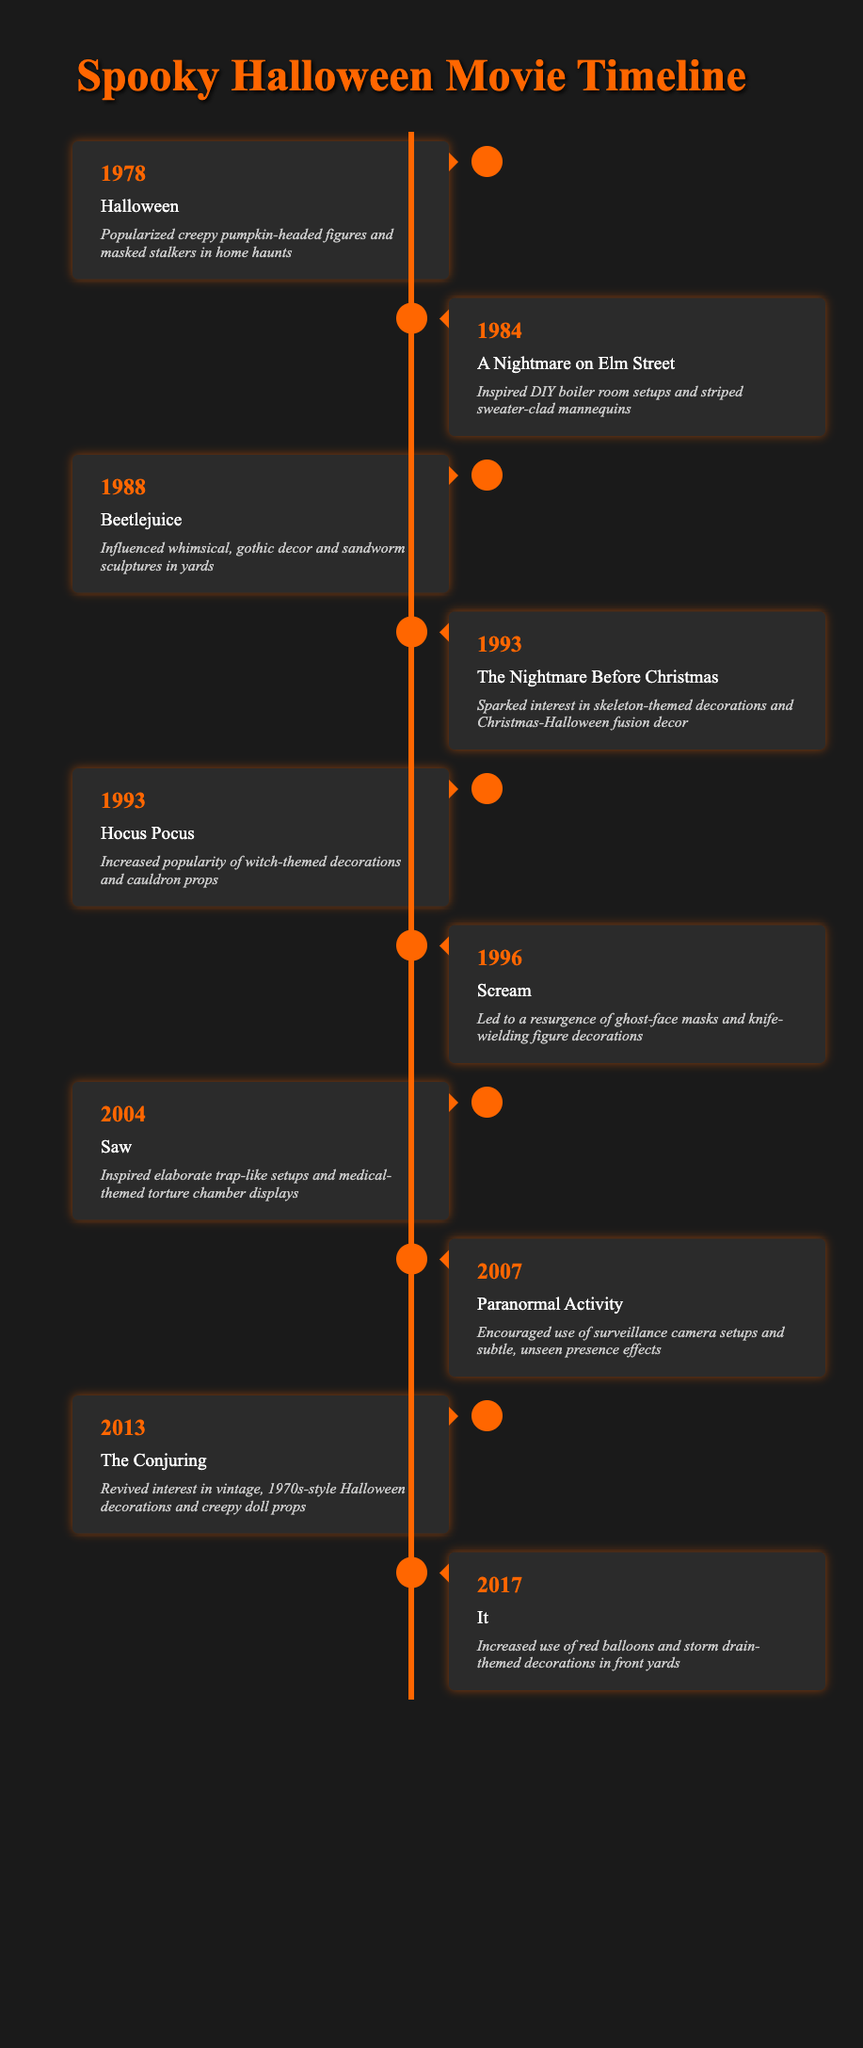What impact did the movie "Hocus Pocus" have on Halloween decorations? "Hocus Pocus" increased the popularity of witch-themed decorations and cauldron props, as stated in the timeline.
Answer: Increased popularity of witch-themed decorations and cauldron props Which movie released in 1993 contributed to skeleton-themed decorations? The timeline shows that "The Nightmare Before Christmas," released in 1993, sparked an interest in skeleton-themed decorations.
Answer: The Nightmare Before Christmas How many movies from the list were released in the 1990s? The years in the table between 1990 and 1999 include "The Nightmare Before Christmas" (1993), "Hocus Pocus" (1993), and "Scream" (1996), totaling three movies.
Answer: 3 Did "Saw" inspire any specific decoration themes? Yes, "Saw" inspired elaborate trap-like setups and medical-themed torture chamber displays, according to its entry in the timeline.
Answer: Yes What year saw the release of "Paranormal Activity"? The timeline indicates that "Paranormal Activity" was released in 2007.
Answer: 2007 Which movie had a notable impact on the use of red balloons in decorations? The timeline states that "It," released in 2017, increased the use of red balloons and storm drain-themed decorations.
Answer: It Which movie's impact led to a resurgence of ghost-face masks and knife-wielding decorations? The timeline shows that "Scream" (1996) led to a resurgence of ghost-face masks and knife-wielding figure decorations.
Answer: Scream If we consider the impact on gothic décor, which movie would be the most influential based on the timeline? "Beetlejuice," released in 1988, influenced whimsical, gothic decor and sandworm sculptures, making it the most influential in this category.
Answer: Beetlejuice How many movies in the timeline were released after the year 2000? The movies released after 2000 are "Saw" (2004), "Paranormal Activity" (2007), "The Conjuring" (2013), and "It" (2017), totaling four movies.
Answer: 4 